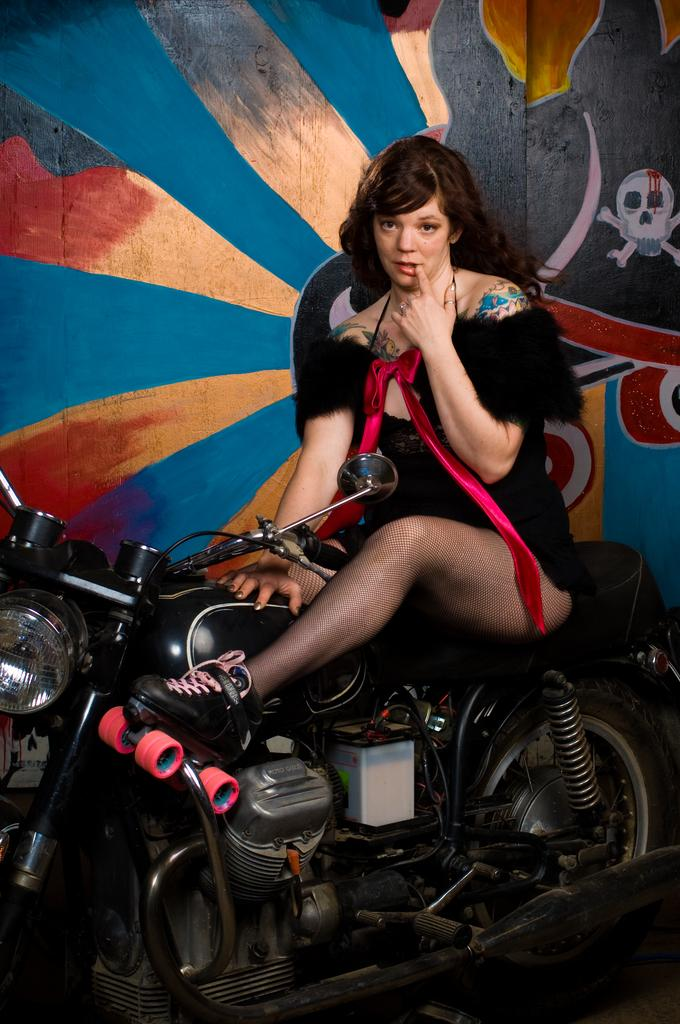Who is the main subject in the image? There is a woman in the image. What is the woman doing in the image? The woman is sitting on a bike. What is the woman wearing in the image? The woman is wearing a black dress and shoes. What is the woman's hairstyle in the image? The woman has short hair. What can be seen in the background of the image? There is a wall and a painting in the background of the image. What type of needle is the woman using to sew a dress in the image? There is no needle or sewing activity present in the image. How many oranges are visible on the wall in the image? There are no oranges visible in the image; only a wall and a painting are present in the background. 